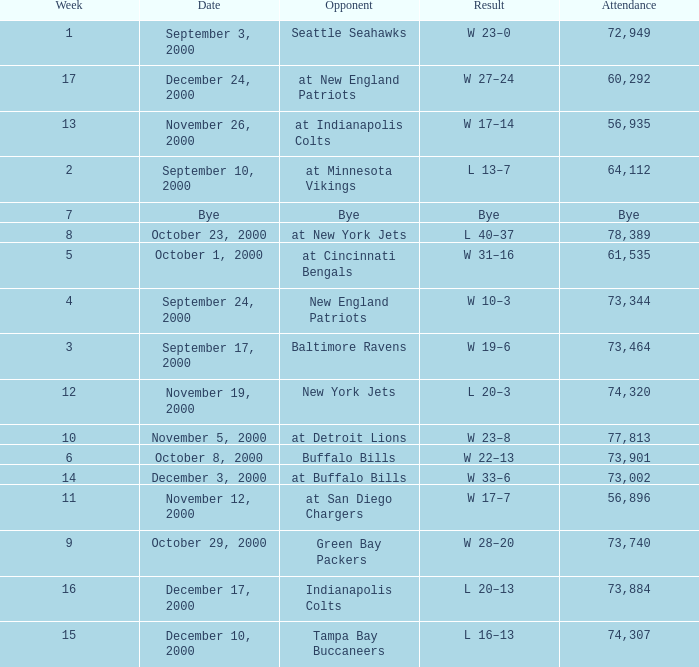I'm looking to parse the entire table for insights. Could you assist me with that? {'header': ['Week', 'Date', 'Opponent', 'Result', 'Attendance'], 'rows': [['1', 'September 3, 2000', 'Seattle Seahawks', 'W 23–0', '72,949'], ['17', 'December 24, 2000', 'at New England Patriots', 'W 27–24', '60,292'], ['13', 'November 26, 2000', 'at Indianapolis Colts', 'W 17–14', '56,935'], ['2', 'September 10, 2000', 'at Minnesota Vikings', 'L 13–7', '64,112'], ['7', 'Bye', 'Bye', 'Bye', 'Bye'], ['8', 'October 23, 2000', 'at New York Jets', 'L 40–37', '78,389'], ['5', 'October 1, 2000', 'at Cincinnati Bengals', 'W 31–16', '61,535'], ['4', 'September 24, 2000', 'New England Patriots', 'W 10–3', '73,344'], ['3', 'September 17, 2000', 'Baltimore Ravens', 'W 19–6', '73,464'], ['12', 'November 19, 2000', 'New York Jets', 'L 20–3', '74,320'], ['10', 'November 5, 2000', 'at Detroit Lions', 'W 23–8', '77,813'], ['6', 'October 8, 2000', 'Buffalo Bills', 'W 22–13', '73,901'], ['14', 'December 3, 2000', 'at Buffalo Bills', 'W 33–6', '73,002'], ['11', 'November 12, 2000', 'at San Diego Chargers', 'W 17–7', '56,896'], ['9', 'October 29, 2000', 'Green Bay Packers', 'W 28–20', '73,740'], ['16', 'December 17, 2000', 'Indianapolis Colts', 'L 20–13', '73,884'], ['15', 'December 10, 2000', 'Tampa Bay Buccaneers', 'L 16–13', '74,307']]} What is the Attendance for a Week earlier than 16, and a Date of bye? Bye. 